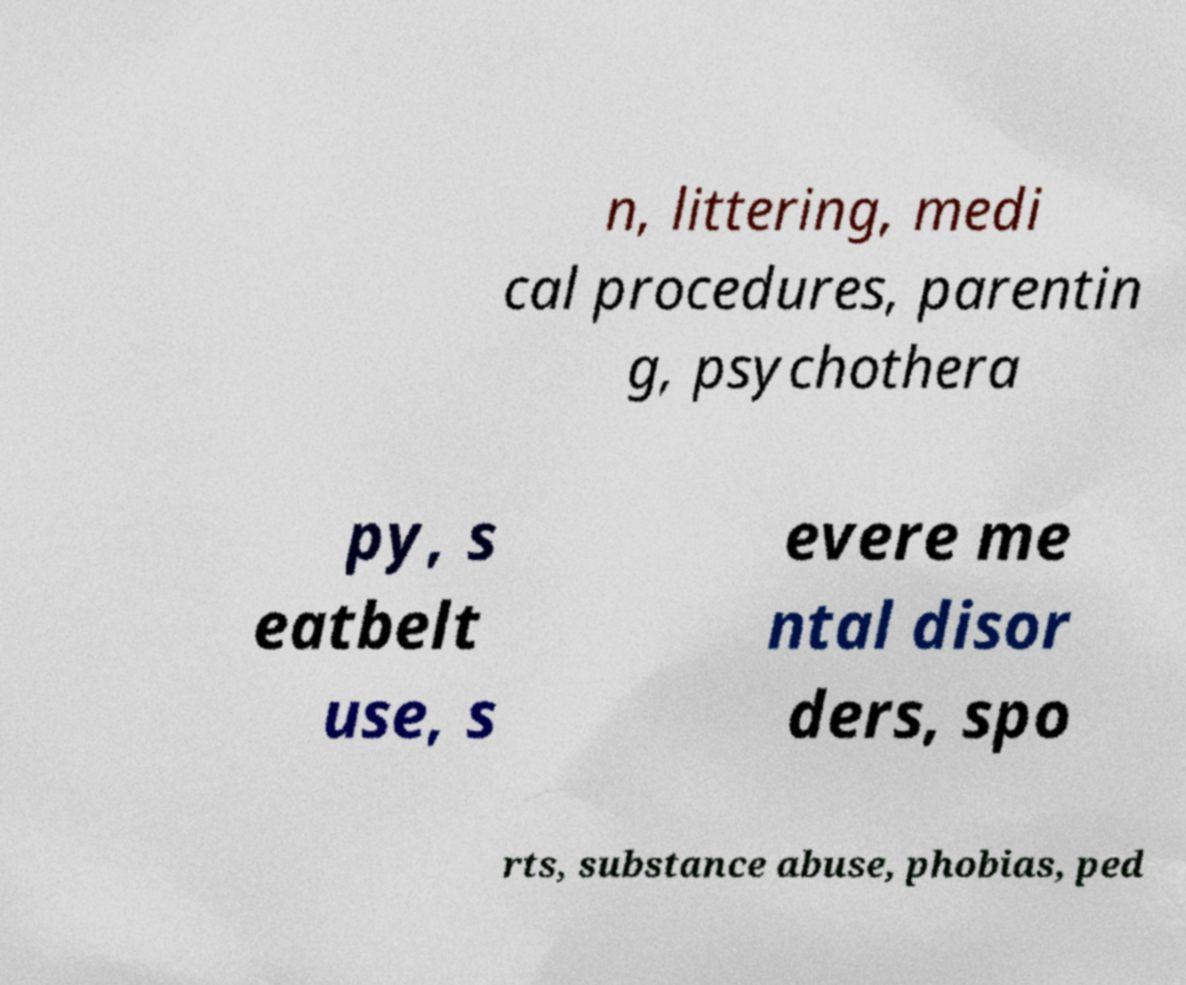Could you assist in decoding the text presented in this image and type it out clearly? n, littering, medi cal procedures, parentin g, psychothera py, s eatbelt use, s evere me ntal disor ders, spo rts, substance abuse, phobias, ped 